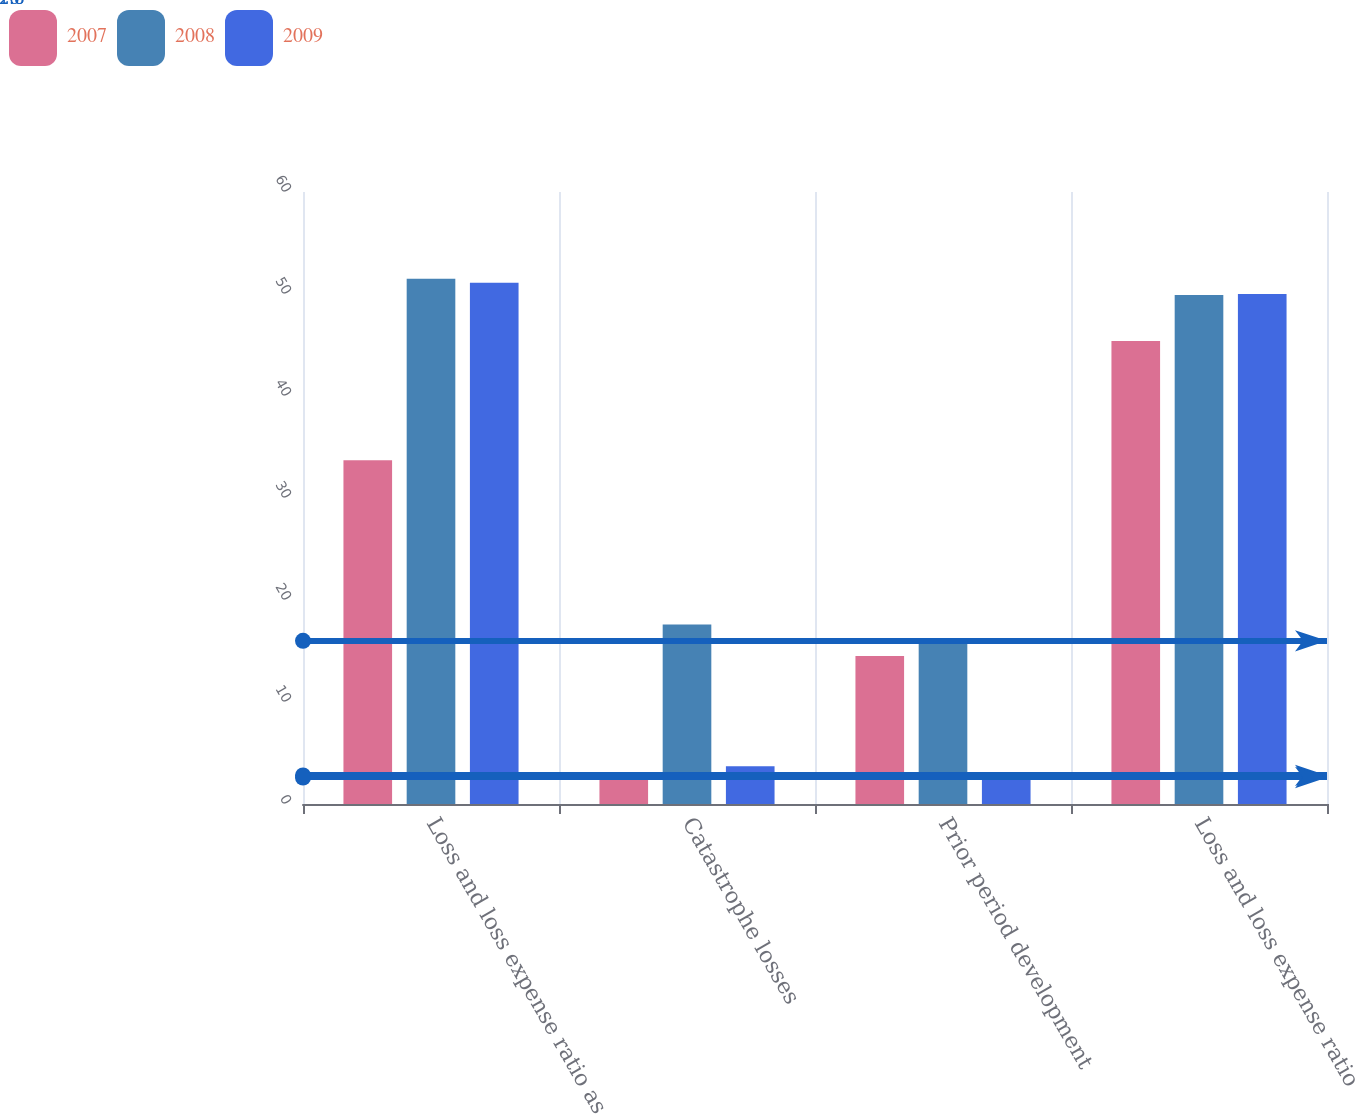<chart> <loc_0><loc_0><loc_500><loc_500><stacked_bar_chart><ecel><fcel>Loss and loss expense ratio as<fcel>Catastrophe losses<fcel>Prior period development<fcel>Loss and loss expense ratio<nl><fcel>2007<fcel>33.7<fcel>2.8<fcel>14.5<fcel>45.4<nl><fcel>2008<fcel>51.5<fcel>17.6<fcel>16<fcel>49.9<nl><fcel>2009<fcel>51.1<fcel>3.7<fcel>2.6<fcel>50<nl></chart> 